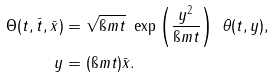Convert formula to latex. <formula><loc_0><loc_0><loc_500><loc_500>\Theta ( t , \bar { t } , \bar { x } ) & = \sqrt { \i m t } \ \exp \left ( \frac { y ^ { 2 } } { \i m t } \right ) \ \theta ( t , y ) , \\ y & = ( \i m t ) \bar { x } .</formula> 